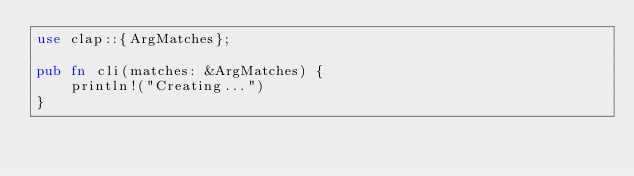<code> <loc_0><loc_0><loc_500><loc_500><_Rust_>use clap::{ArgMatches};

pub fn cli(matches: &ArgMatches) {
    println!("Creating...")
}
</code> 